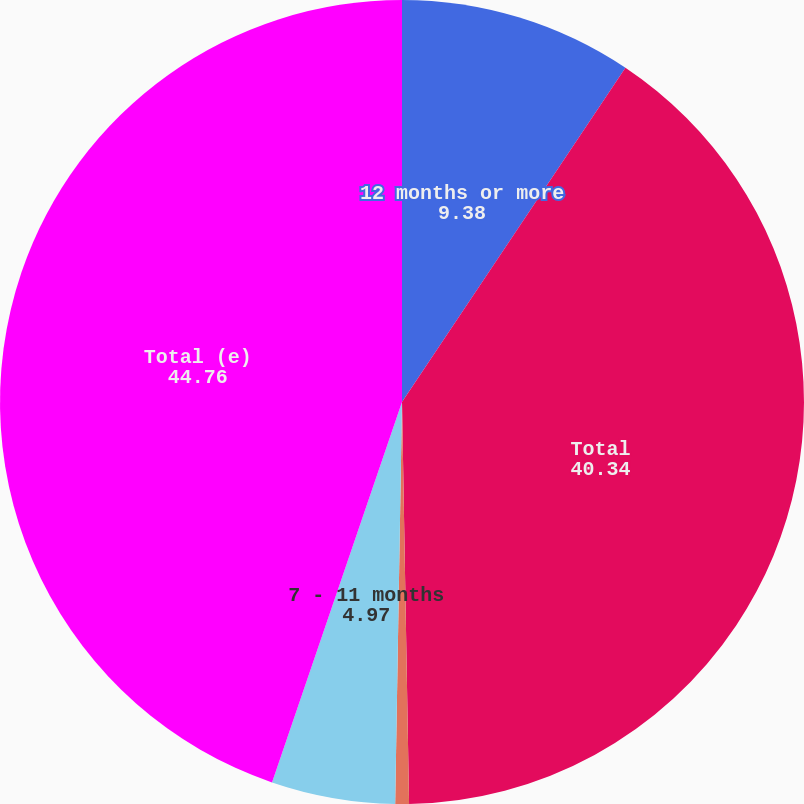Convert chart. <chart><loc_0><loc_0><loc_500><loc_500><pie_chart><fcel>12 months or more<fcel>Total<fcel>0 - 6 months<fcel>7 - 11 months<fcel>Total (e)<nl><fcel>9.38%<fcel>40.34%<fcel>0.55%<fcel>4.97%<fcel>44.76%<nl></chart> 